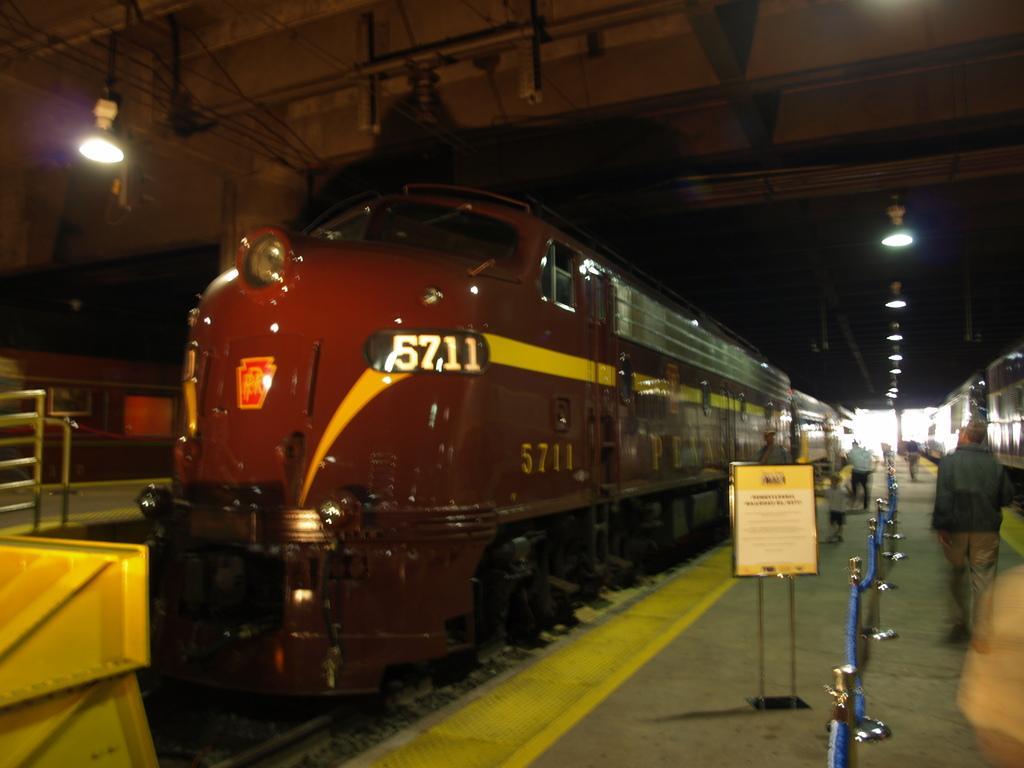Can you describe this image briefly? Here there is a train on the track, here there is an advertisement board, this is light, people are walking here. 